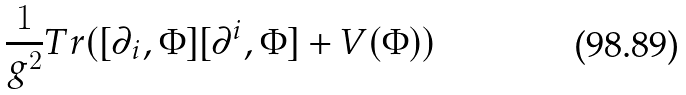<formula> <loc_0><loc_0><loc_500><loc_500>\frac { 1 } { g ^ { 2 } } T r ( [ \partial _ { i } , \Phi ] [ \partial ^ { i } , \Phi ] + V ( \Phi ) )</formula> 